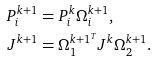Convert formula to latex. <formula><loc_0><loc_0><loc_500><loc_500>P _ { i } ^ { k + 1 } & = P _ { i } ^ { k } \Omega _ { i } ^ { k + 1 } , \\ J ^ { k + 1 } & = \Omega _ { 1 } ^ { k + 1 ^ { T } } J ^ { k } \Omega _ { 2 } ^ { k + 1 } . \\</formula> 